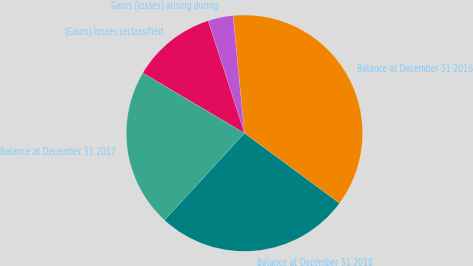Convert chart. <chart><loc_0><loc_0><loc_500><loc_500><pie_chart><fcel>Balance at December 31 2016<fcel>Gains (losses) arising during<fcel>(Gains) losses reclassified<fcel>Balance at December 31 2017<fcel>Balance at December 31 2018<nl><fcel>36.64%<fcel>3.44%<fcel>11.52%<fcel>21.68%<fcel>26.72%<nl></chart> 